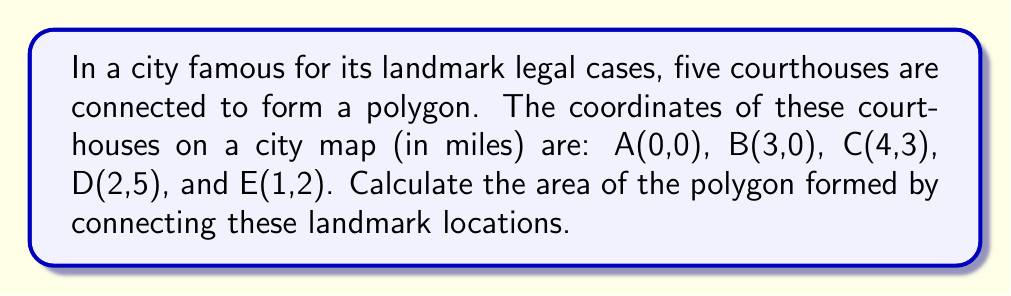What is the answer to this math problem? Let's approach this step-by-step using the Shoelace formula (also known as the surveyor's formula):

1) The Shoelace formula for the area of a polygon with vertices $(x_1, y_1), (x_2, y_2), ..., (x_n, y_n)$ is:

   $$Area = \frac{1}{2}|(x_1y_2 + x_2y_3 + ... + x_ny_1) - (y_1x_2 + y_2x_3 + ... + y_nx_1)|$$

2) Let's organize our data:
   A(0,0), B(3,0), C(4,3), D(2,5), E(1,2)

3) Applying the formula:

   $$\begin{align}
   Area &= \frac{1}{2}|(0\cdot0 + 3\cdot3 + 4\cdot5 + 2\cdot2 + 1\cdot0) \\
   &\quad - (0\cdot3 + 0\cdot4 + 3\cdot2 + 5\cdot1 + 2\cdot0)|
   \end{align}$$

4) Simplify:

   $$\begin{align}
   Area &= \frac{1}{2}|(0 + 9 + 20 + 4 + 0) - (0 + 0 + 6 + 5 + 0)| \\
   &= \frac{1}{2}|33 - 11| \\
   &= \frac{1}{2}(22) \\
   &= 11
   \end{align}$$

Therefore, the area of the polygon is 11 square miles.
Answer: 11 square miles 